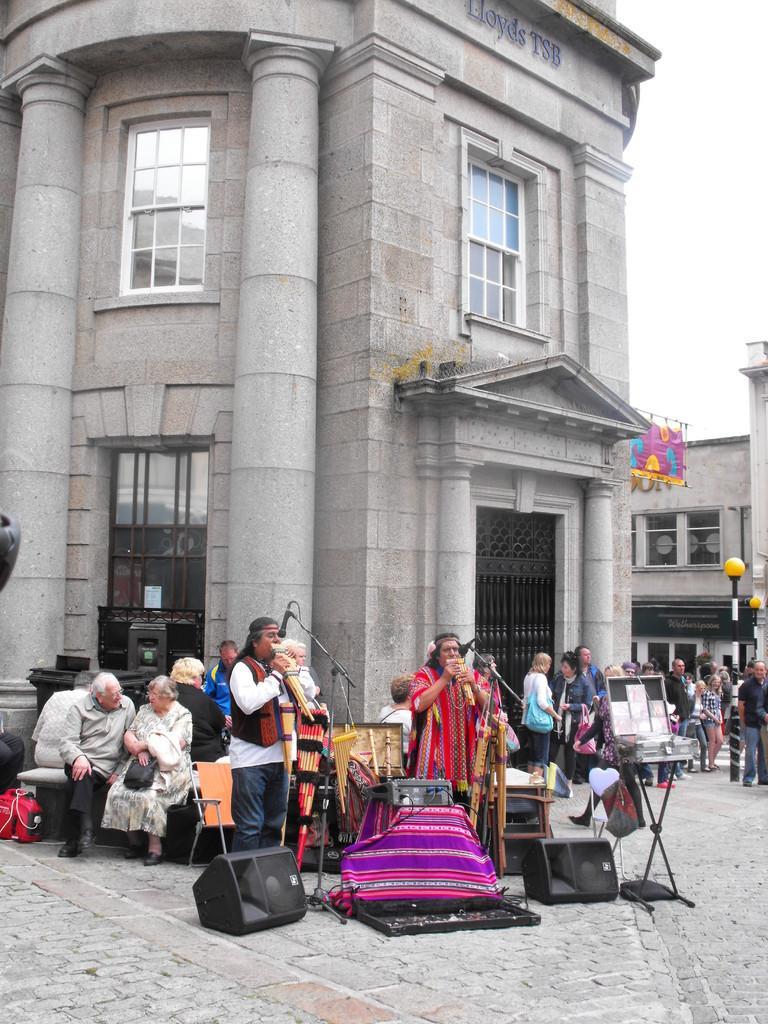How would you summarize this image in a sentence or two? In the background we can see the sky, buildings, windows, gate. In this picture we can see the people. On the left side we can see the people are sitting. In this picture we can see the chairs and few objects on the floor. We can see people playing musical instruments. We can see the microphones and the stands. On the right side of the picture we can see the lights, poles and at the top we can see a colorful cloth is hanging. 